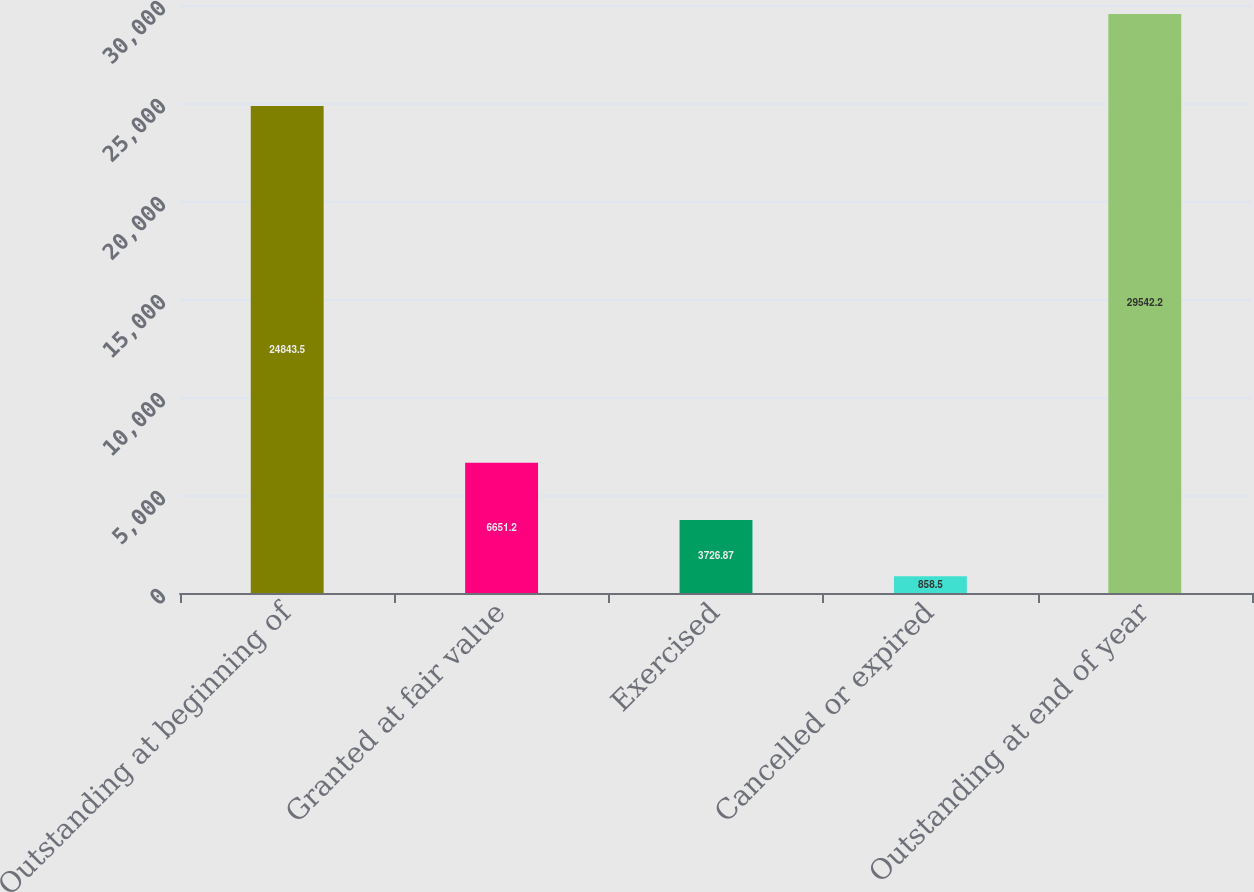<chart> <loc_0><loc_0><loc_500><loc_500><bar_chart><fcel>Outstanding at beginning of<fcel>Granted at fair value<fcel>Exercised<fcel>Cancelled or expired<fcel>Outstanding at end of year<nl><fcel>24843.5<fcel>6651.2<fcel>3726.87<fcel>858.5<fcel>29542.2<nl></chart> 